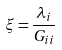<formula> <loc_0><loc_0><loc_500><loc_500>\xi = \frac { \lambda _ { i } } { G _ { i i } }</formula> 